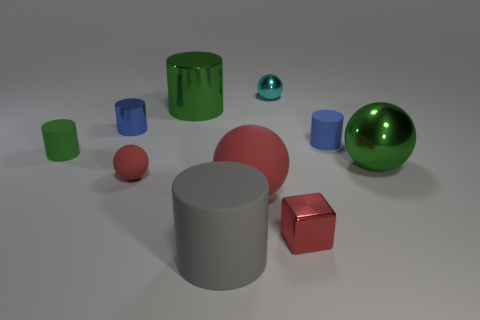Subtract all gray cylinders. How many cylinders are left? 4 Subtract 3 cylinders. How many cylinders are left? 2 Subtract all blue shiny cylinders. How many cylinders are left? 4 Subtract all brown spheres. Subtract all yellow cylinders. How many spheres are left? 4 Subtract all balls. How many objects are left? 6 Add 1 small things. How many small things are left? 7 Add 1 cyan shiny objects. How many cyan shiny objects exist? 2 Subtract 0 cyan blocks. How many objects are left? 10 Subtract all large matte spheres. Subtract all big spheres. How many objects are left? 7 